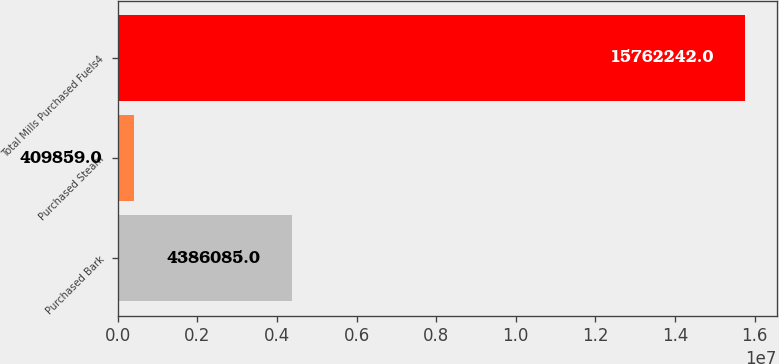<chart> <loc_0><loc_0><loc_500><loc_500><bar_chart><fcel>Purchased Bark<fcel>Purchased Steam<fcel>Total Mills Purchased Fuels4<nl><fcel>4.38608e+06<fcel>409859<fcel>1.57622e+07<nl></chart> 